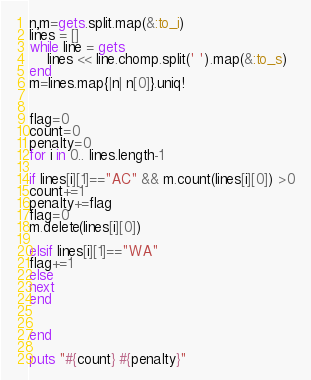Convert code to text. <code><loc_0><loc_0><loc_500><loc_500><_Ruby_>n,m=gets.split.map(&:to_i)
lines = []
while line = gets
    lines << line.chomp.split(' ').map(&:to_s)
end
m=lines.map{|n| n[0]}.uniq!


flag=0
count=0
penalty=0
for i in 0.. lines.length-1
    
if lines[i][1]=="AC" && m.count(lines[i][0]) >0
count+=1
penalty+=flag
flag=0
m.delete(lines[i][0])

elsif lines[i][1]=="WA"
flag+=1
else
next
end
    
    
end

puts "#{count} #{penalty}"</code> 